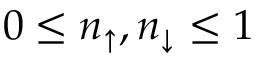<formula> <loc_0><loc_0><loc_500><loc_500>0 \leq n _ { \uparrow } , n _ { \downarrow } \leq 1</formula> 